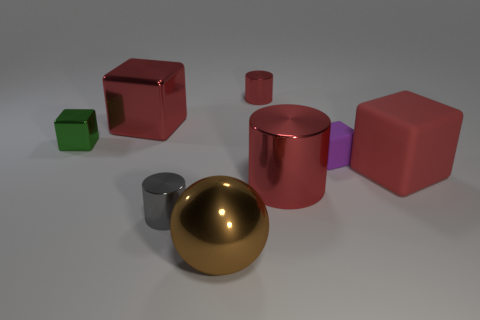Add 2 green things. How many objects exist? 10 Subtract all balls. How many objects are left? 7 Subtract 0 green cylinders. How many objects are left? 8 Subtract all tiny red metallic objects. Subtract all small red objects. How many objects are left? 6 Add 6 green shiny cubes. How many green shiny cubes are left? 7 Add 6 small cyan cylinders. How many small cyan cylinders exist? 6 